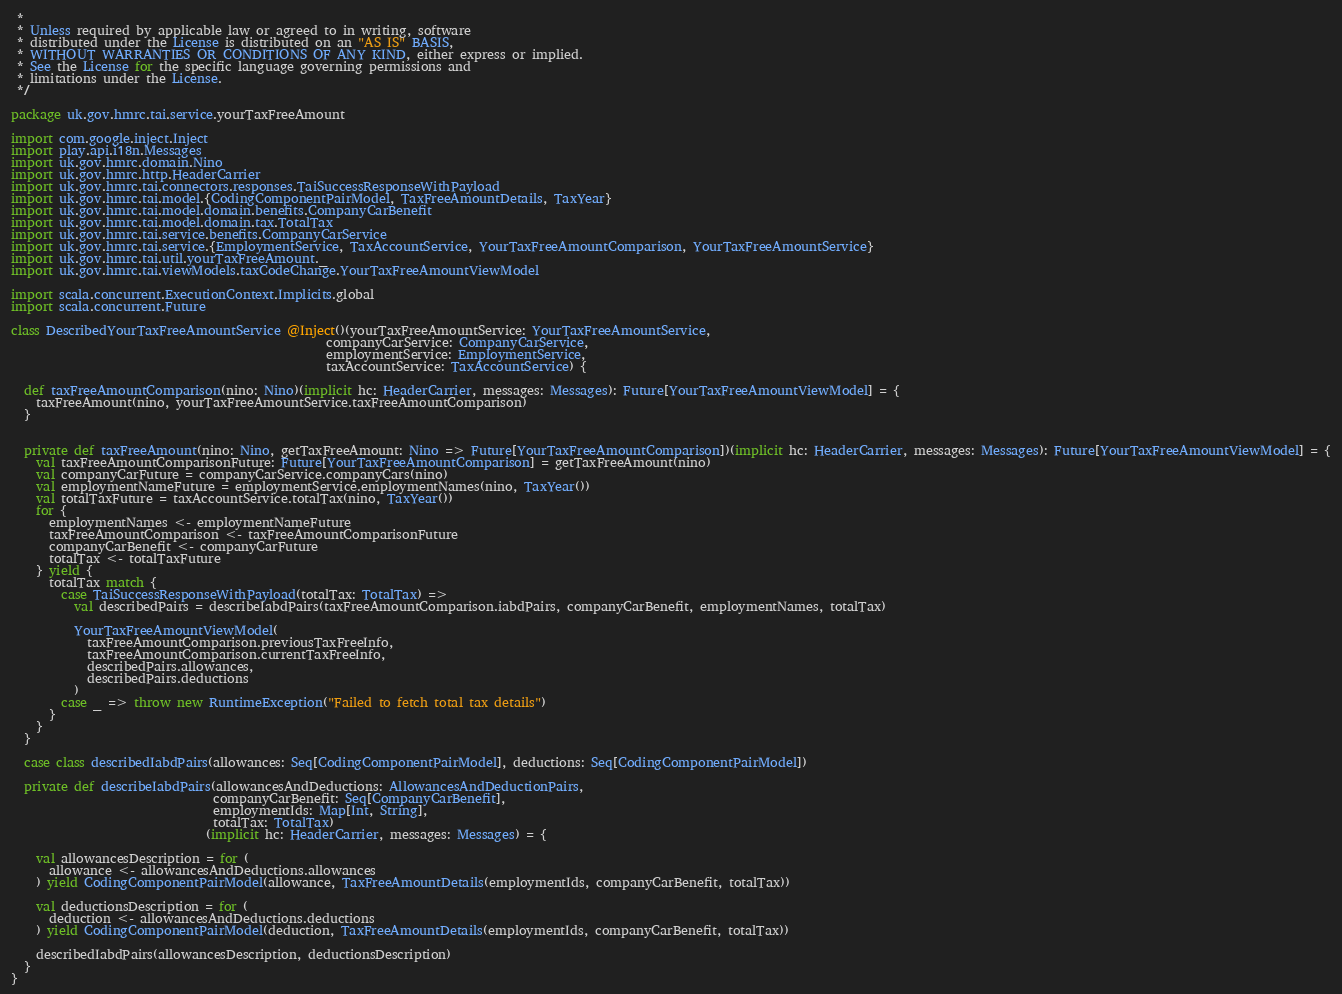Convert code to text. <code><loc_0><loc_0><loc_500><loc_500><_Scala_> *
 * Unless required by applicable law or agreed to in writing, software
 * distributed under the License is distributed on an "AS IS" BASIS,
 * WITHOUT WARRANTIES OR CONDITIONS OF ANY KIND, either express or implied.
 * See the License for the specific language governing permissions and
 * limitations under the License.
 */

package uk.gov.hmrc.tai.service.yourTaxFreeAmount

import com.google.inject.Inject
import play.api.i18n.Messages
import uk.gov.hmrc.domain.Nino
import uk.gov.hmrc.http.HeaderCarrier
import uk.gov.hmrc.tai.connectors.responses.TaiSuccessResponseWithPayload
import uk.gov.hmrc.tai.model.{CodingComponentPairModel, TaxFreeAmountDetails, TaxYear}
import uk.gov.hmrc.tai.model.domain.benefits.CompanyCarBenefit
import uk.gov.hmrc.tai.model.domain.tax.TotalTax
import uk.gov.hmrc.tai.service.benefits.CompanyCarService
import uk.gov.hmrc.tai.service.{EmploymentService, TaxAccountService, YourTaxFreeAmountComparison, YourTaxFreeAmountService}
import uk.gov.hmrc.tai.util.yourTaxFreeAmount._
import uk.gov.hmrc.tai.viewModels.taxCodeChange.YourTaxFreeAmountViewModel

import scala.concurrent.ExecutionContext.Implicits.global
import scala.concurrent.Future

class DescribedYourTaxFreeAmountService @Inject()(yourTaxFreeAmountService: YourTaxFreeAmountService,
                                                  companyCarService: CompanyCarService,
                                                  employmentService: EmploymentService,
                                                  taxAccountService: TaxAccountService) {

  def taxFreeAmountComparison(nino: Nino)(implicit hc: HeaderCarrier, messages: Messages): Future[YourTaxFreeAmountViewModel] = {
    taxFreeAmount(nino, yourTaxFreeAmountService.taxFreeAmountComparison)
  }


  private def taxFreeAmount(nino: Nino, getTaxFreeAmount: Nino => Future[YourTaxFreeAmountComparison])(implicit hc: HeaderCarrier, messages: Messages): Future[YourTaxFreeAmountViewModel] = {
    val taxFreeAmountComparisonFuture: Future[YourTaxFreeAmountComparison] = getTaxFreeAmount(nino)
    val companyCarFuture = companyCarService.companyCars(nino)
    val employmentNameFuture = employmentService.employmentNames(nino, TaxYear())
    val totalTaxFuture = taxAccountService.totalTax(nino, TaxYear())
    for {
      employmentNames <- employmentNameFuture
      taxFreeAmountComparison <- taxFreeAmountComparisonFuture
      companyCarBenefit <- companyCarFuture
      totalTax <- totalTaxFuture
    } yield {
      totalTax match {
        case TaiSuccessResponseWithPayload(totalTax: TotalTax) =>
          val describedPairs = describeIabdPairs(taxFreeAmountComparison.iabdPairs, companyCarBenefit, employmentNames, totalTax)

          YourTaxFreeAmountViewModel(
            taxFreeAmountComparison.previousTaxFreeInfo,
            taxFreeAmountComparison.currentTaxFreeInfo,
            describedPairs.allowances,
            describedPairs.deductions
          )
        case _ => throw new RuntimeException("Failed to fetch total tax details")
      }
    }
  }

  case class describedIabdPairs(allowances: Seq[CodingComponentPairModel], deductions: Seq[CodingComponentPairModel])

  private def describeIabdPairs(allowancesAndDeductions: AllowancesAndDeductionPairs,
                                companyCarBenefit: Seq[CompanyCarBenefit],
                                employmentIds: Map[Int, String],
                                totalTax: TotalTax)
                               (implicit hc: HeaderCarrier, messages: Messages) = {

    val allowancesDescription = for (
      allowance <- allowancesAndDeductions.allowances
    ) yield CodingComponentPairModel(allowance, TaxFreeAmountDetails(employmentIds, companyCarBenefit, totalTax))

    val deductionsDescription = for (
      deduction <- allowancesAndDeductions.deductions
    ) yield CodingComponentPairModel(deduction, TaxFreeAmountDetails(employmentIds, companyCarBenefit, totalTax))

    describedIabdPairs(allowancesDescription, deductionsDescription)
  }
}
</code> 